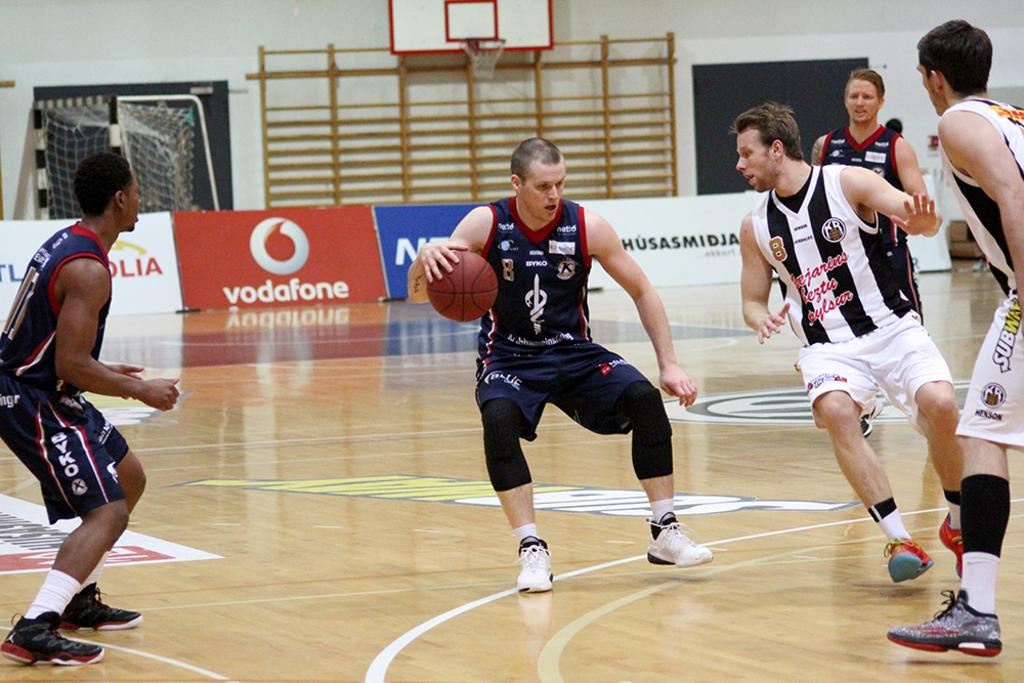<image>
Give a short and clear explanation of the subsequent image. Basketball players play a game in an arena with Vodafone ads. 